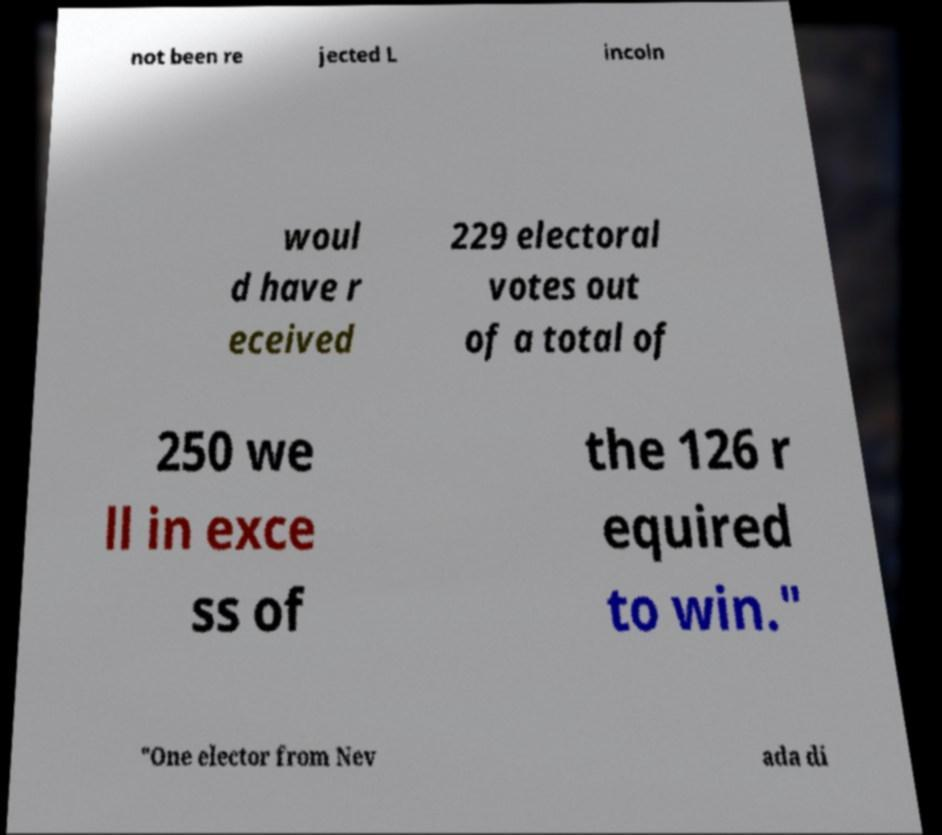I need the written content from this picture converted into text. Can you do that? not been re jected L incoln woul d have r eceived 229 electoral votes out of a total of 250 we ll in exce ss of the 126 r equired to win." "One elector from Nev ada di 